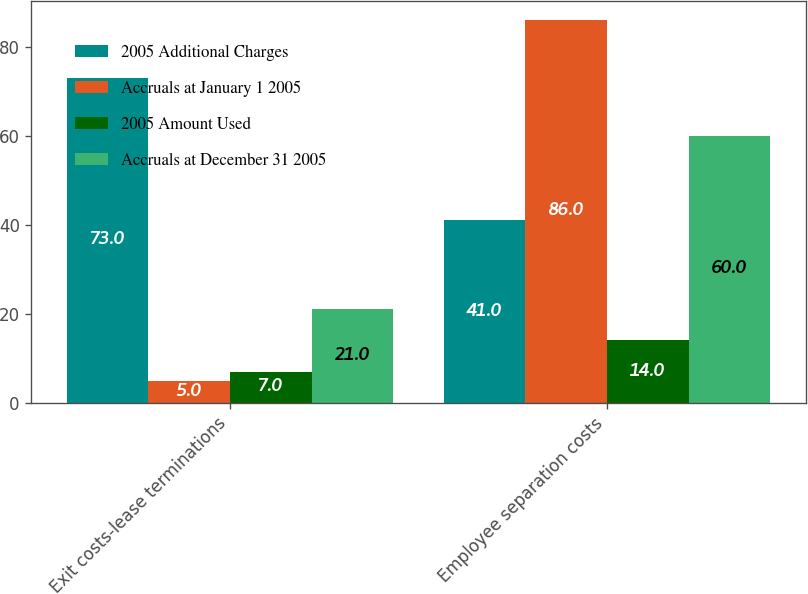Convert chart to OTSL. <chart><loc_0><loc_0><loc_500><loc_500><stacked_bar_chart><ecel><fcel>Exit costs-lease terminations<fcel>Employee separation costs<nl><fcel>2005 Additional Charges<fcel>73<fcel>41<nl><fcel>Accruals at January 1 2005<fcel>5<fcel>86<nl><fcel>2005 Amount Used<fcel>7<fcel>14<nl><fcel>Accruals at December 31 2005<fcel>21<fcel>60<nl></chart> 